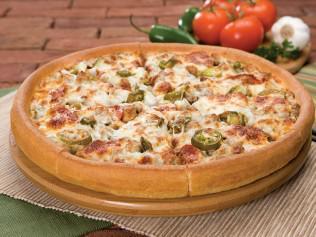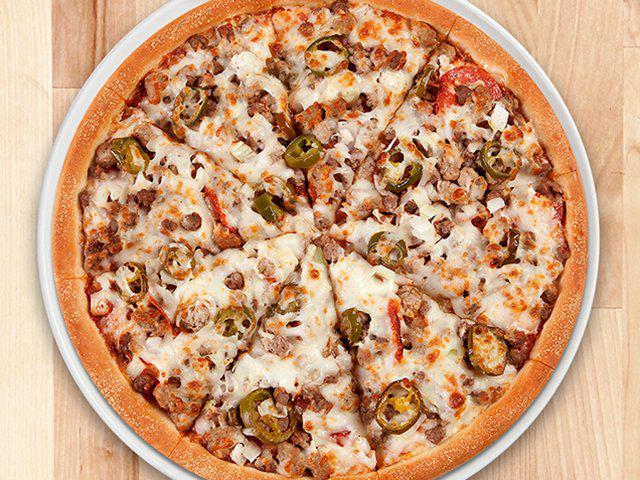The first image is the image on the left, the second image is the image on the right. Assess this claim about the two images: "Two whole baked pizzas are covered with toppings and melted cheese, one of them in a cardboard delivery box.". Correct or not? Answer yes or no. No. The first image is the image on the left, the second image is the image on the right. Considering the images on both sides, is "there is a pizza in a carboard box" valid? Answer yes or no. No. 